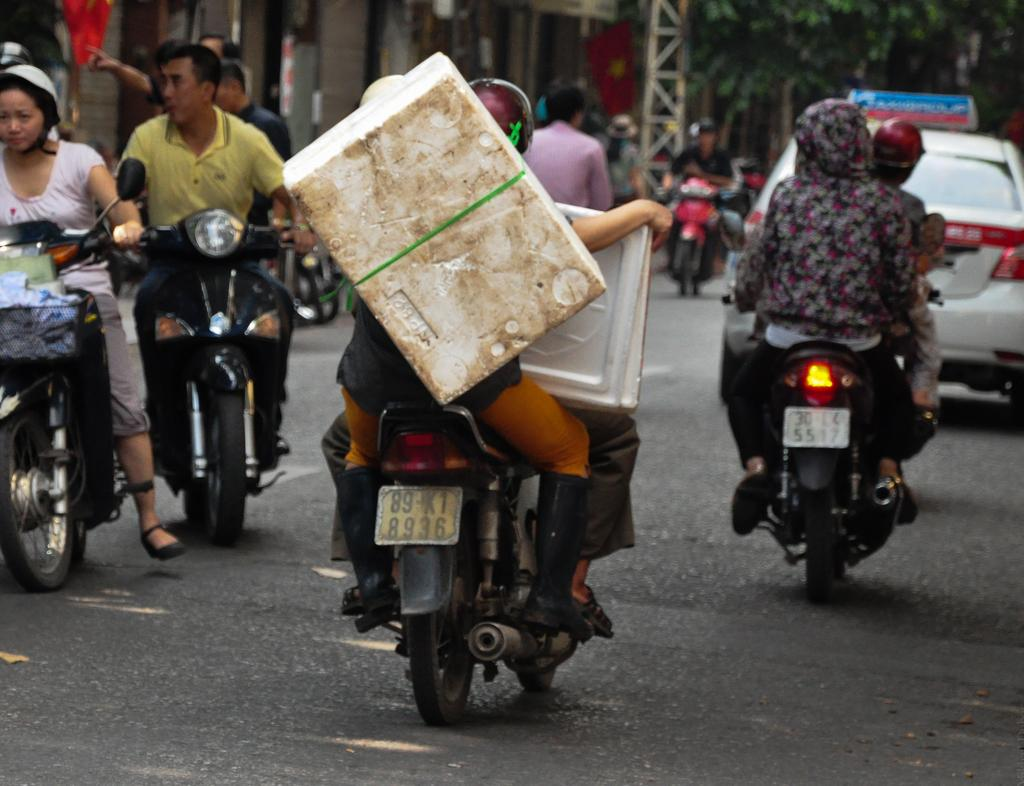What type of setting is depicted in the image? The image is an outdoor scene. What are the people doing in the image? People are sitting on a motorbike. Is the motorbike moving or stationary? The motorbike is in motion. What other vehicles can be seen in the image? A white car is visible on the road. What can be seen in the distance in the image? There are trees and a flag in the distance. What type of disgust can be seen on the faces of the people sitting on the motorbike? There is no indication of disgust on the faces of the people sitting on the motorbike in the image. Who is the porter in the image? There is no porter present in the image. 